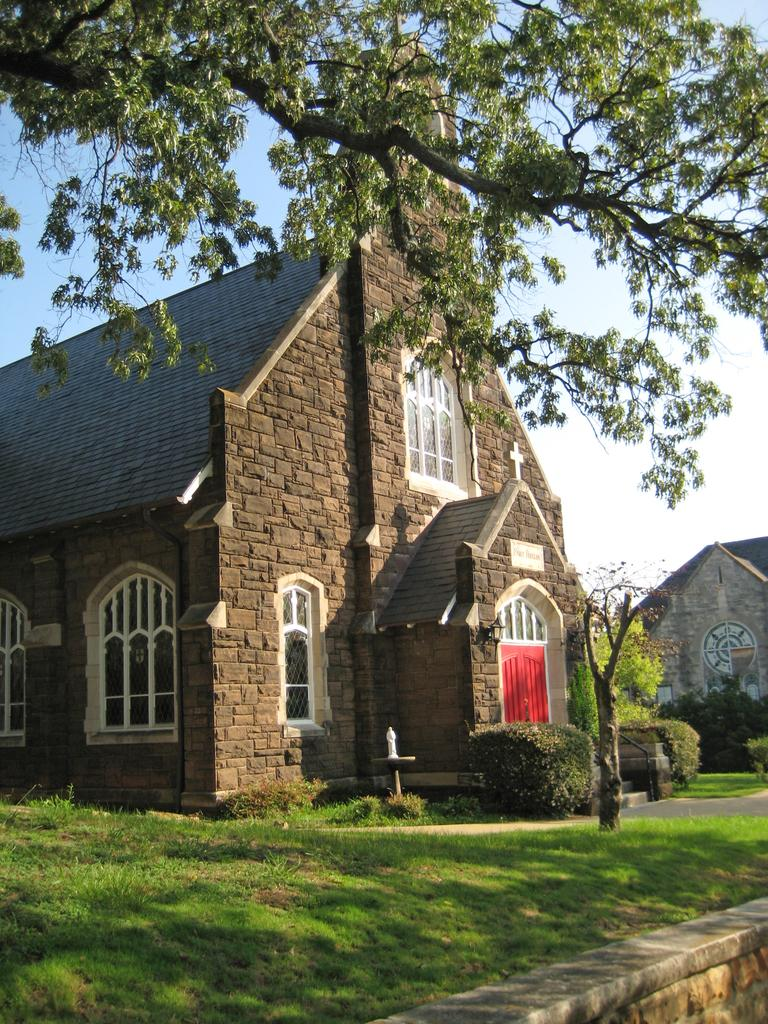What type of vegetation can be seen in the image? There is grass, plants, and trees in the image. What structures are present in the image? There are buildings in the image. What part of the natural environment is visible in the image? The sky is visible in the image. What type of food is being served in the image? There is no food present in the image; it features grass, plants, trees, buildings, and the sky. What season is depicted in the image? The provided facts do not mention any specific season, so it cannot be determined from the image. 